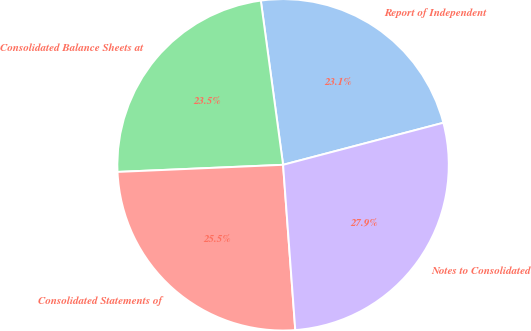Convert chart to OTSL. <chart><loc_0><loc_0><loc_500><loc_500><pie_chart><fcel>Report of Independent<fcel>Consolidated Balance Sheets at<fcel>Consolidated Statements of<fcel>Notes to Consolidated<nl><fcel>23.06%<fcel>23.54%<fcel>25.49%<fcel>27.91%<nl></chart> 